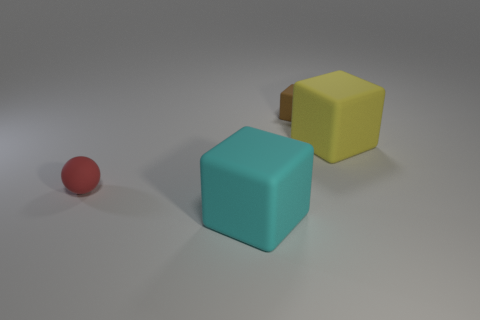Do the large rubber cube behind the tiny red object and the tiny rubber cube have the same color?
Keep it short and to the point. No. What material is the big object behind the small red object?
Keep it short and to the point. Rubber. Are there the same number of red balls that are behind the red thing and big cylinders?
Your response must be concise. Yes. How many cubes are the same color as the tiny rubber ball?
Your answer should be very brief. 0. There is another small rubber object that is the same shape as the cyan matte thing; what is its color?
Your answer should be compact. Brown. Do the cyan object and the brown matte cube have the same size?
Make the answer very short. No. Are there the same number of small rubber objects that are behind the red matte thing and small brown things that are in front of the brown matte cube?
Keep it short and to the point. No. Is there a yellow object?
Ensure brevity in your answer.  Yes. What size is the cyan object that is the same shape as the small brown rubber object?
Your answer should be compact. Large. What size is the thing that is in front of the ball?
Make the answer very short. Large. 